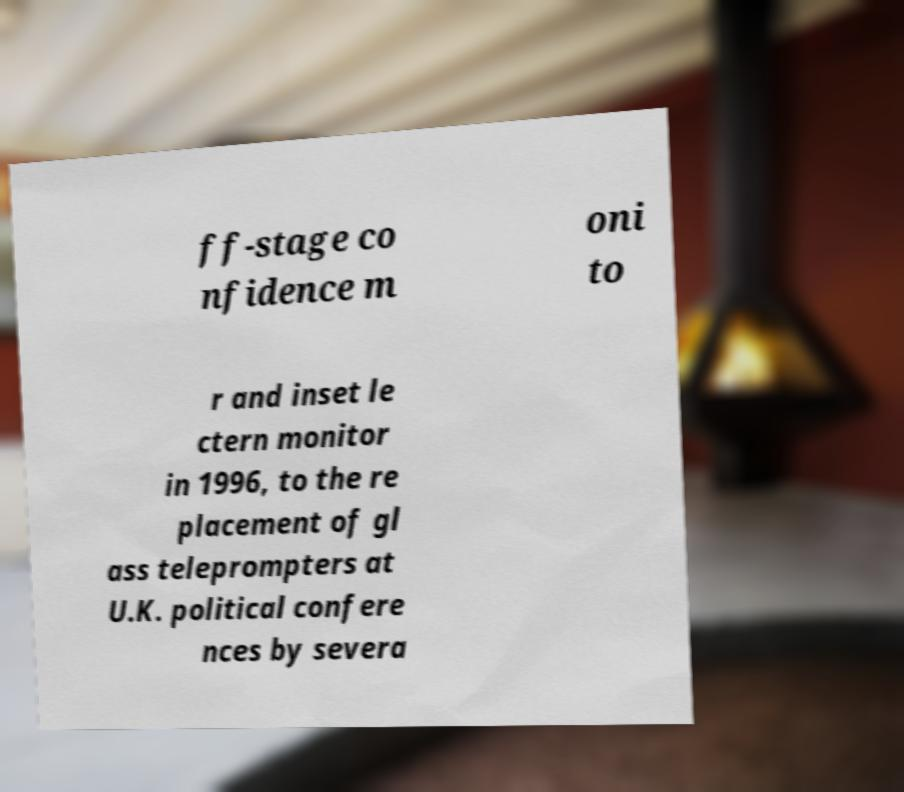Please identify and transcribe the text found in this image. ff-stage co nfidence m oni to r and inset le ctern monitor in 1996, to the re placement of gl ass teleprompters at U.K. political confere nces by severa 